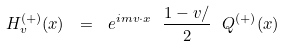Convert formula to latex. <formula><loc_0><loc_0><loc_500><loc_500>H _ { v } ^ { ( + ) } ( x ) \ = \ e ^ { i m v { \cdot } x } \ \frac { 1 - v { \slash } } { 2 } \ Q ^ { ( + ) } ( x )</formula> 